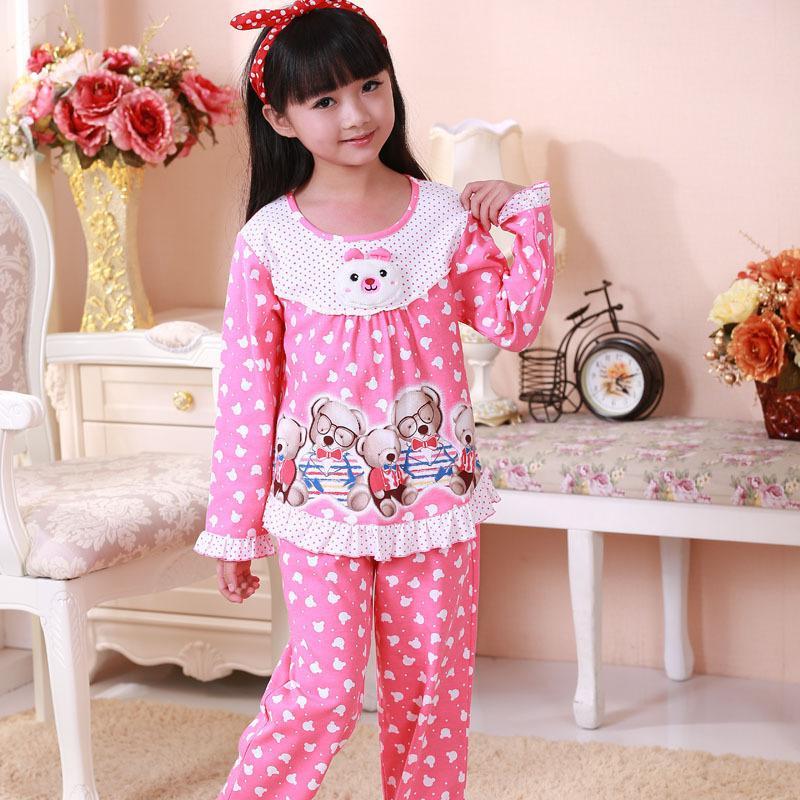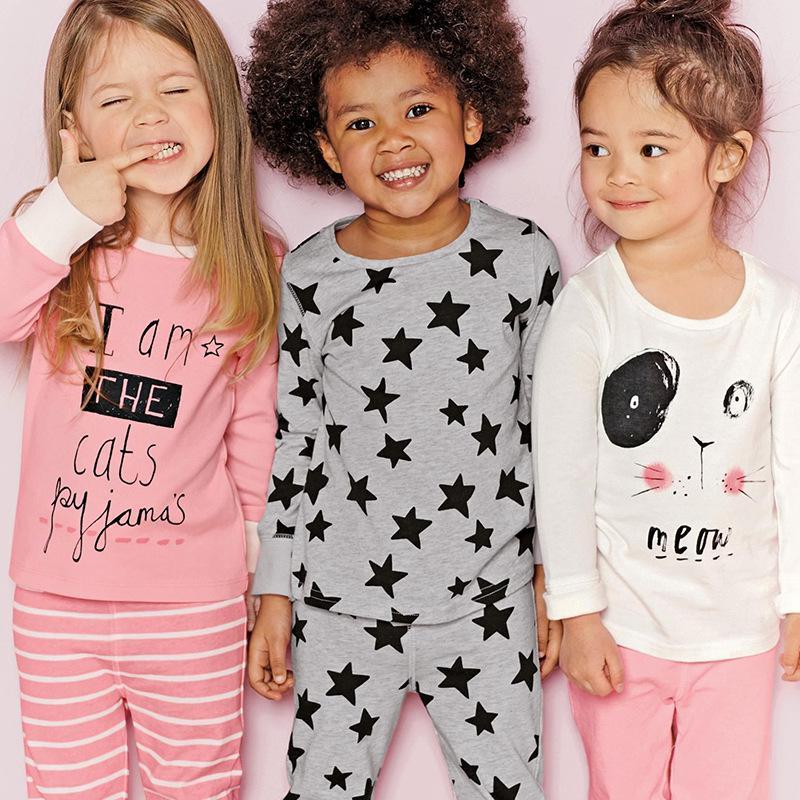The first image is the image on the left, the second image is the image on the right. Examine the images to the left and right. Is the description "The right image contains three children." accurate? Answer yes or no. Yes. The first image is the image on the left, the second image is the image on the right. Examine the images to the left and right. Is the description "One girl is wearing shorts." accurate? Answer yes or no. No. 